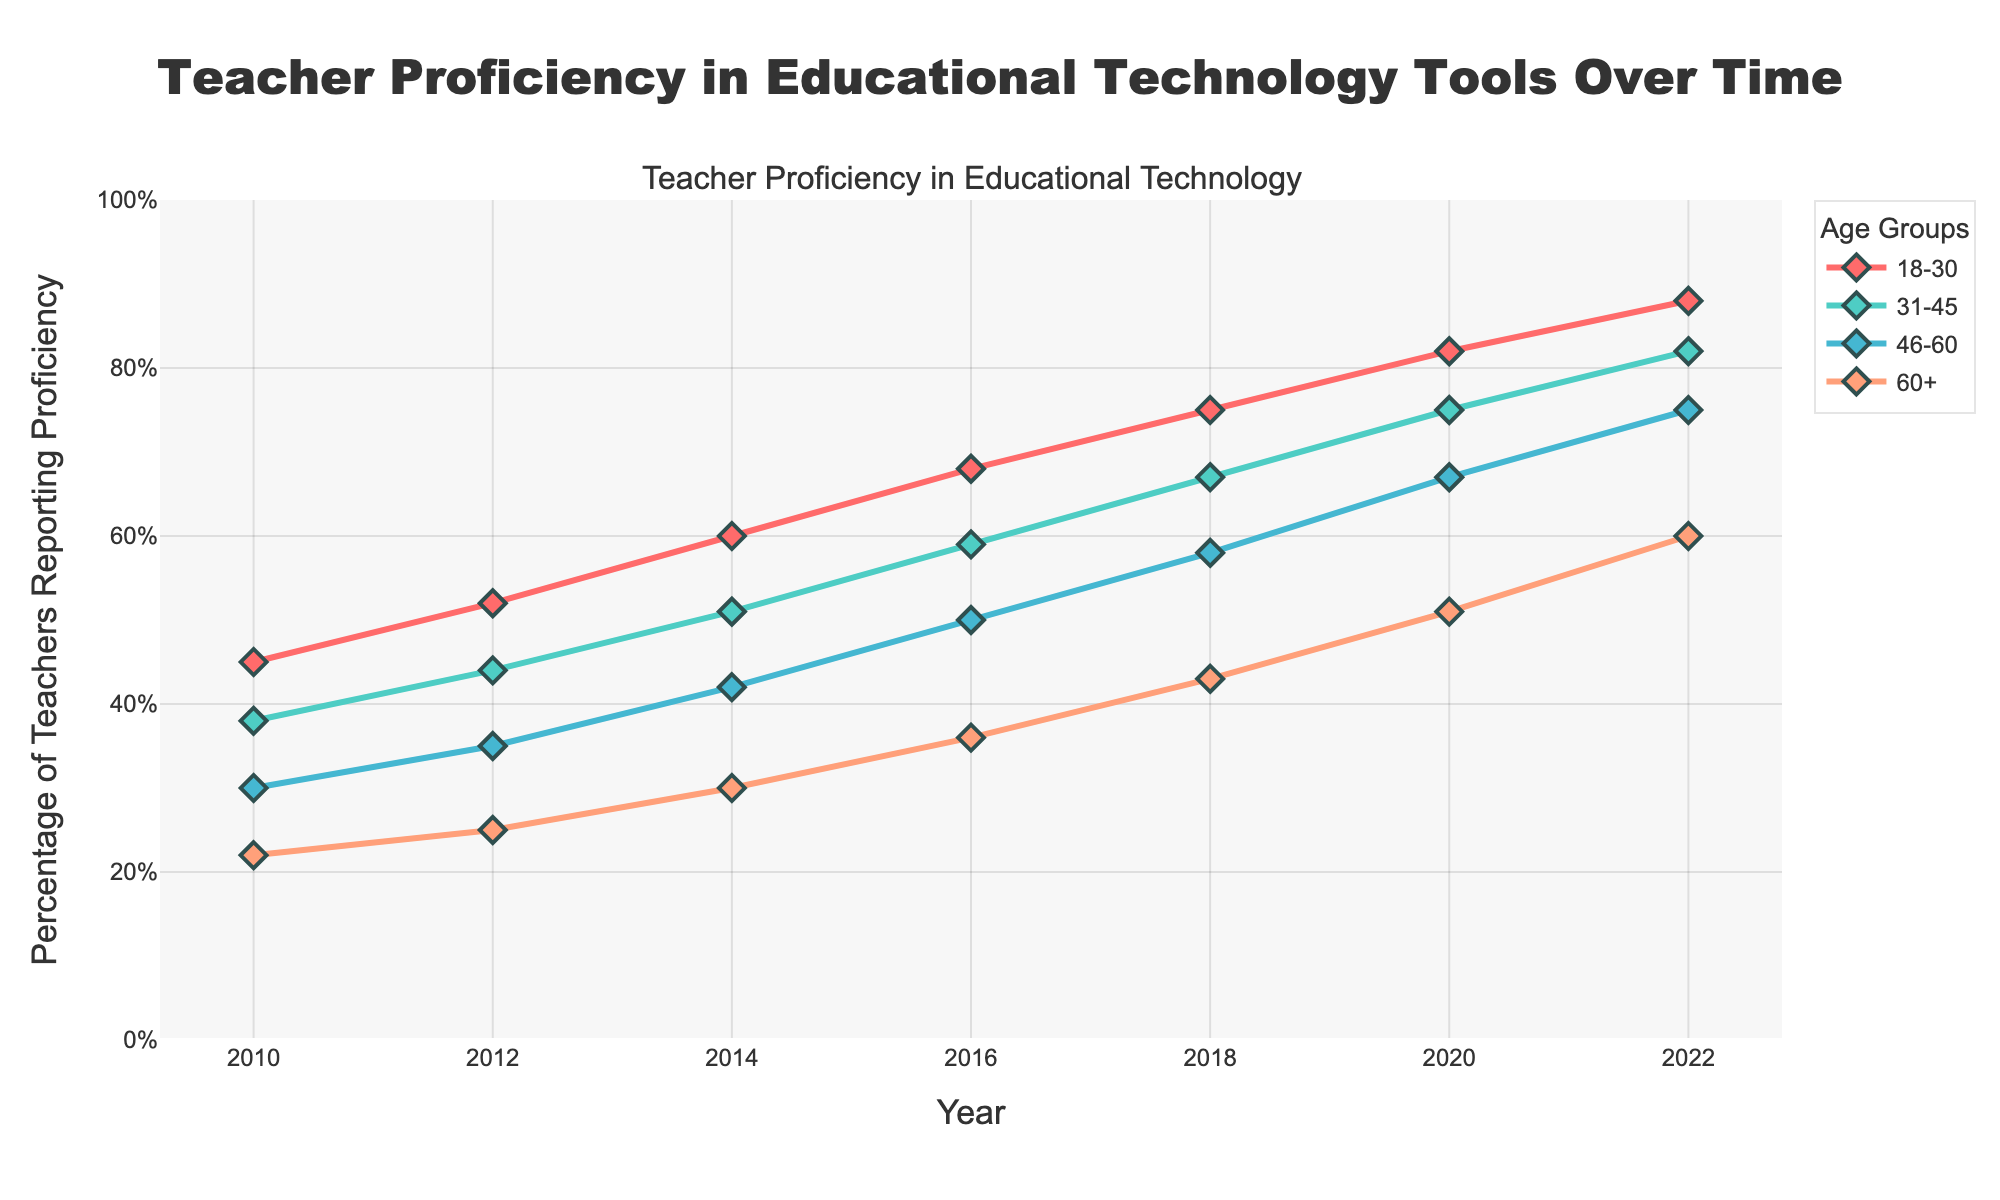What is the percentage increase in the proficiency of teachers aged 18-30 from 2010 to 2022? The percentage in 2010 is 45%, and in 2022 it is 88%. The increase is calculated as 88% - 45% = 43%.
Answer: 43% Which age group had the least proficiency in using educational technology tools in 2014? By checking the line chart for 2014, the 60+ age group had the lowest proficiency at 30%.
Answer: 60+ In which year did the 31-45 age group surpass 50% proficiency? The proficiency for the 31-45 age group was 51% in 2014, which is the first year it surpassed 50%.
Answer: 2014 How did the proficiency of the 46-60 age group change between 2016 and 2020? In 2016, the proficiency was 50%, and in 2020 it was 67%. The change is calculated as 67% - 50% = 17%.
Answer: 17% Which age group had the largest increase in proficiency between 2018 and 2022? The increases are: 18-30 (88%-75% = 13%), 31-45 (82%-67% = 15%), 46-60 (75%-58% = 17%), 60+ (60%-43% = 17%). The 46-60 and 60+ groups both had the largest increase of 17%.
Answer: 46-60, 60+ In 2022, compare the proficiency percentages of the 31-45 and 46-60 age groups. Which was higher and by how much? In 2022, the 31-45 group had 82% proficiency and the 46-60 group had 75%. The 31-45 group was higher by 82% - 75% = 7%.
Answer: 31-45, 7% Which age group showed a consistent increase in proficiency every recorded year from 2010 to 2022? All age groups show a consistent increase in proficiency in each recorded year.
Answer: All groups By how much did the proficiency for the 60+ age group increase from 2010 to 2016? The proficiency in 2010 was 22% and in 2016 it was 36%. The increase is calculated as 36% - 22% = 14%.
Answer: 14% What was the average proficiency percentage of the 18-30 age group over the recorded years? The percentages are 45, 52, 60, 68, 75, 82, 88. The average is (45 + 52 + 60 + 68 + 75 + 82 + 88)/7 = 470/7 ≈ 67.14%.
Answer: 67.14% 